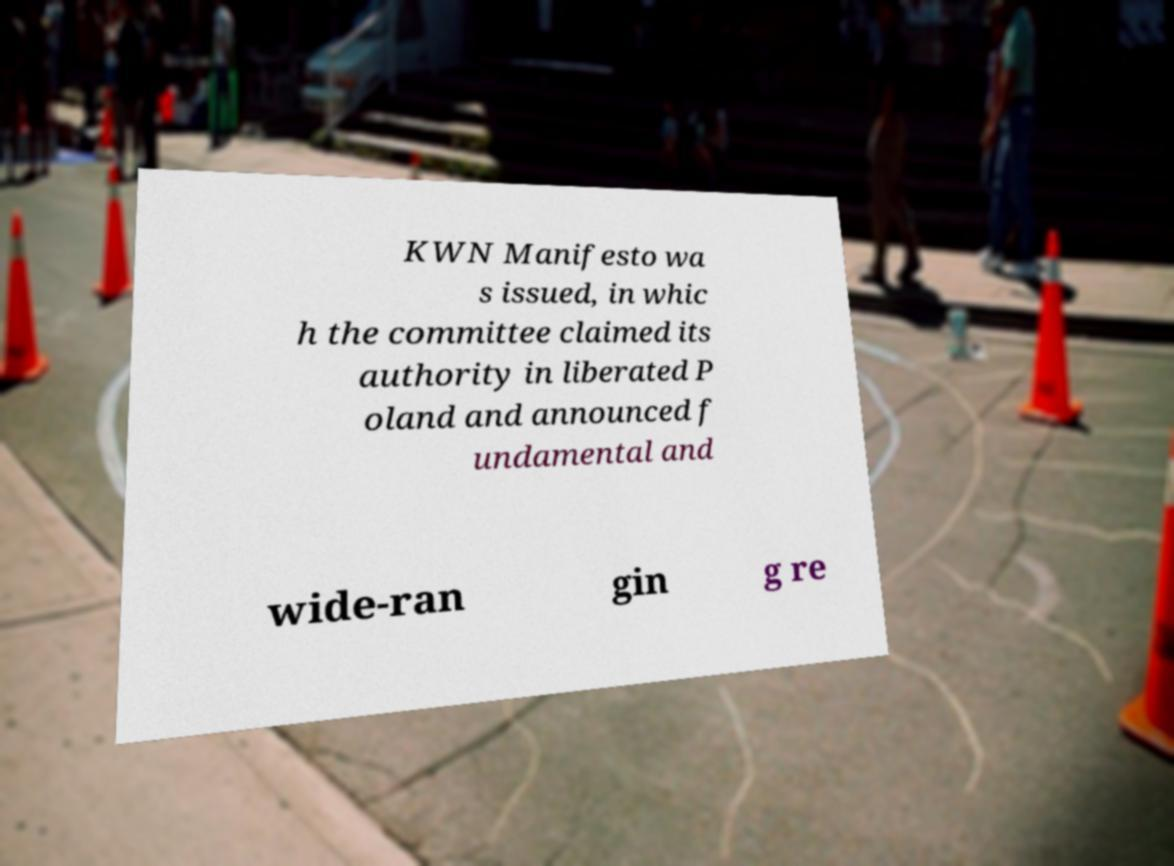Please read and relay the text visible in this image. What does it say? KWN Manifesto wa s issued, in whic h the committee claimed its authority in liberated P oland and announced f undamental and wide-ran gin g re 